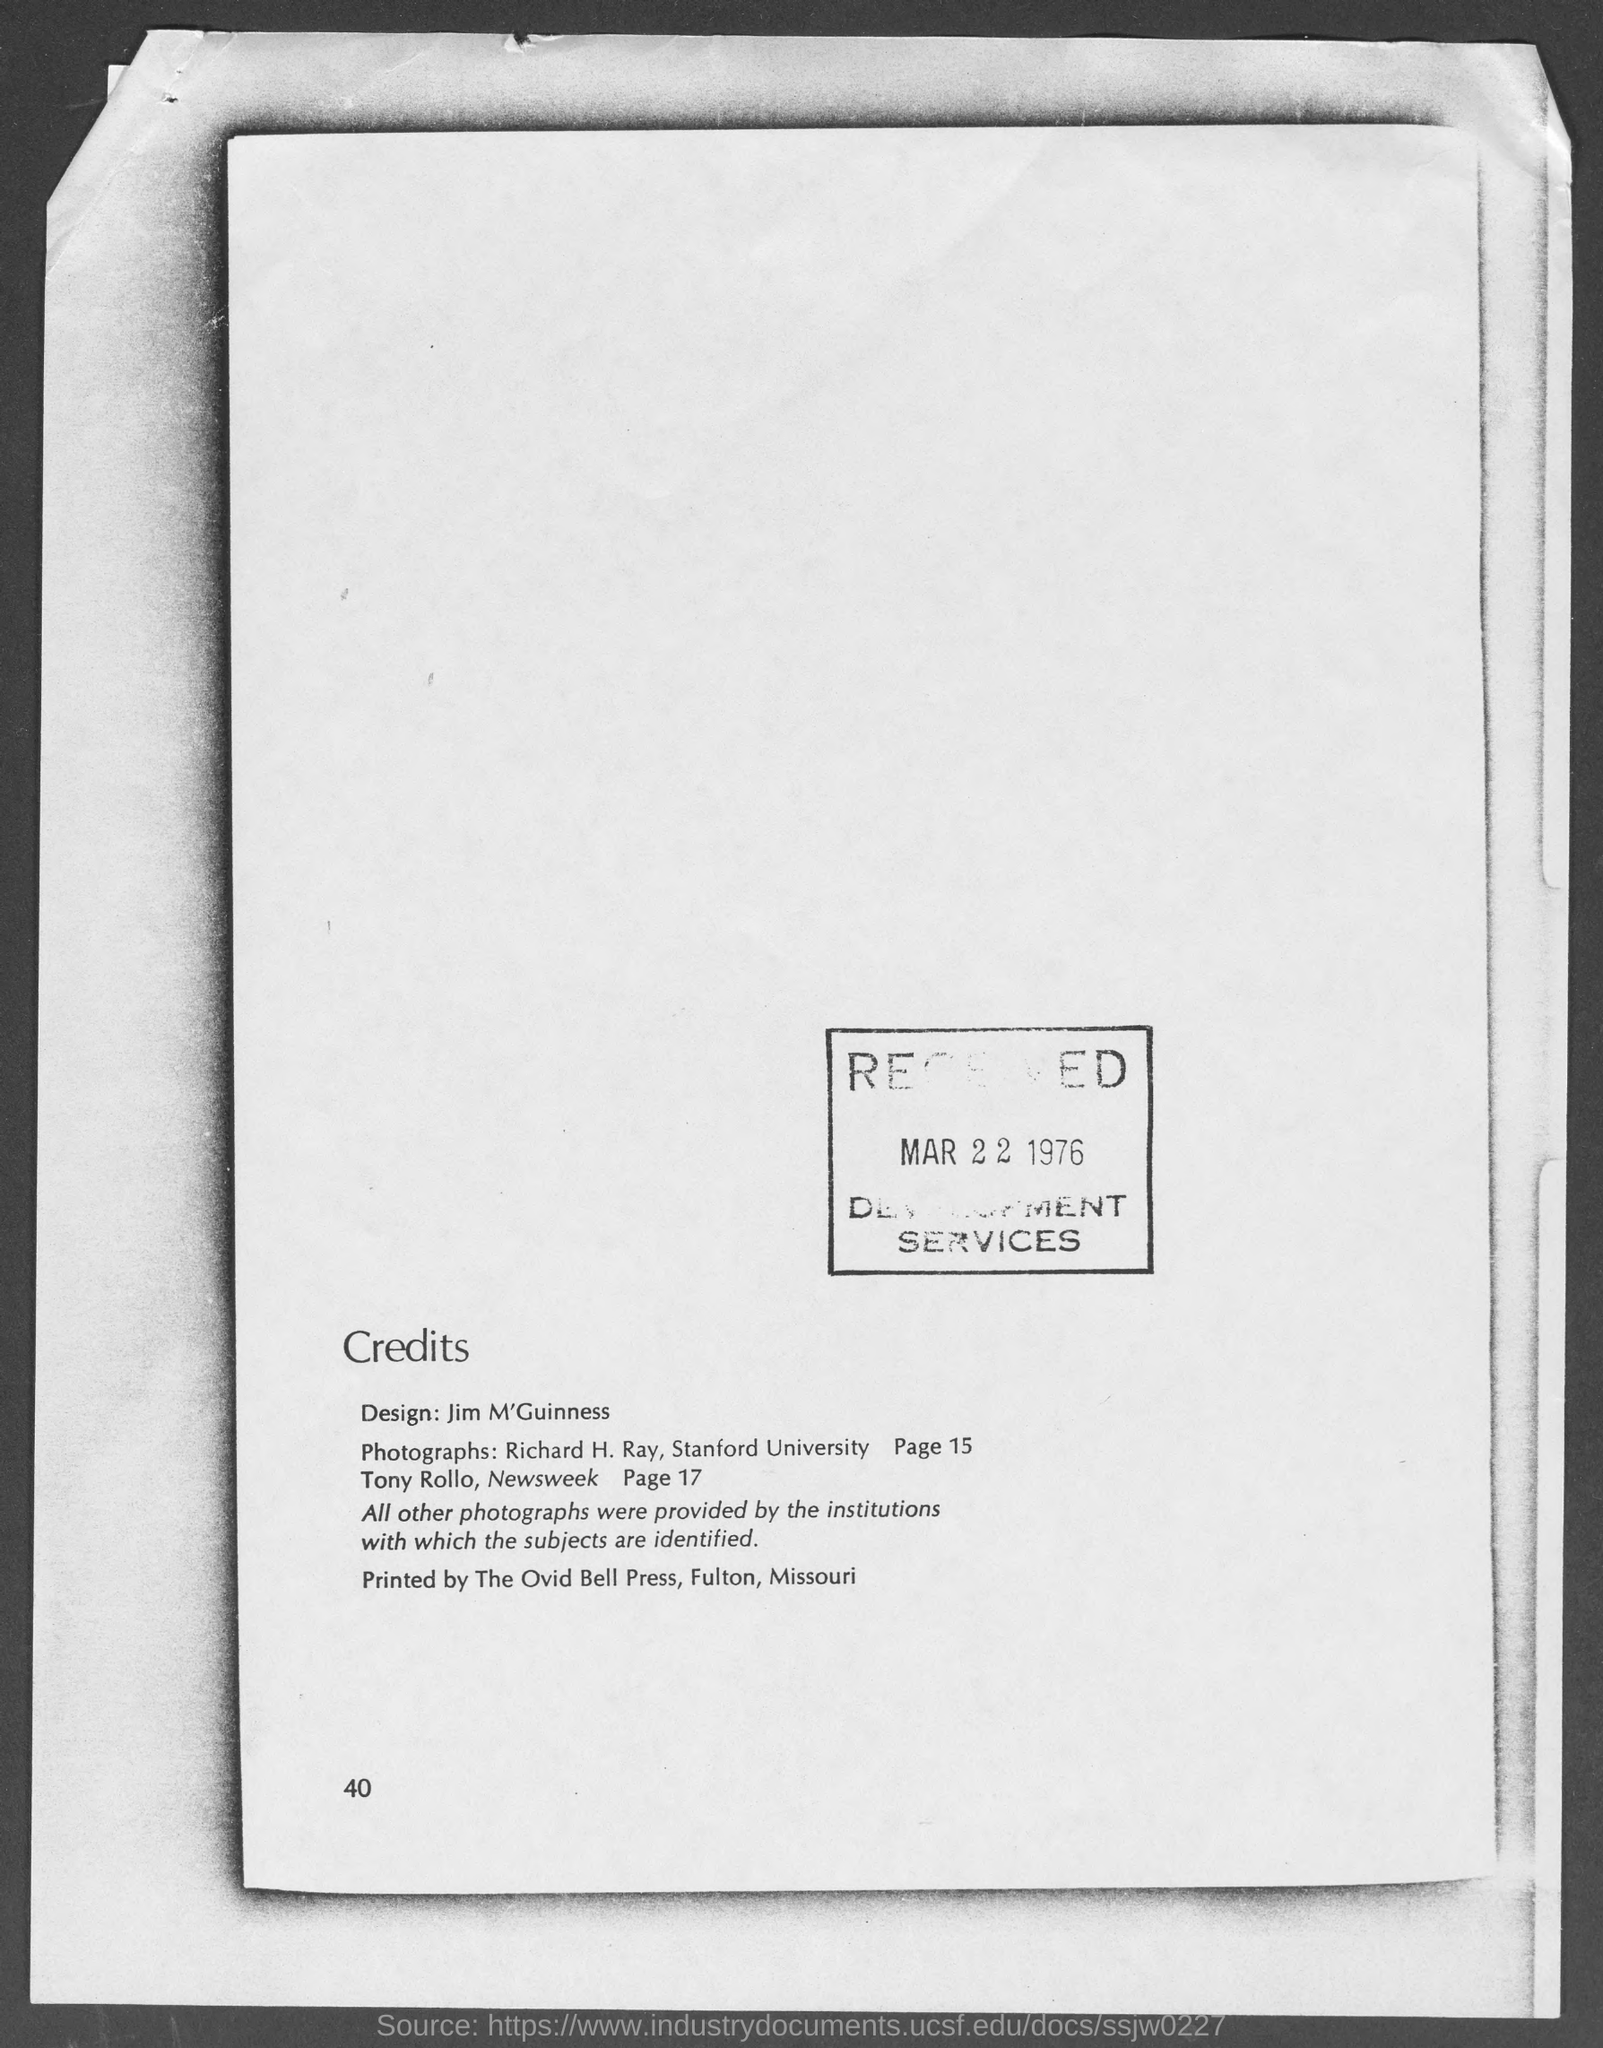List a handful of essential elements in this visual. The page number at the bottom of the page is 40. 